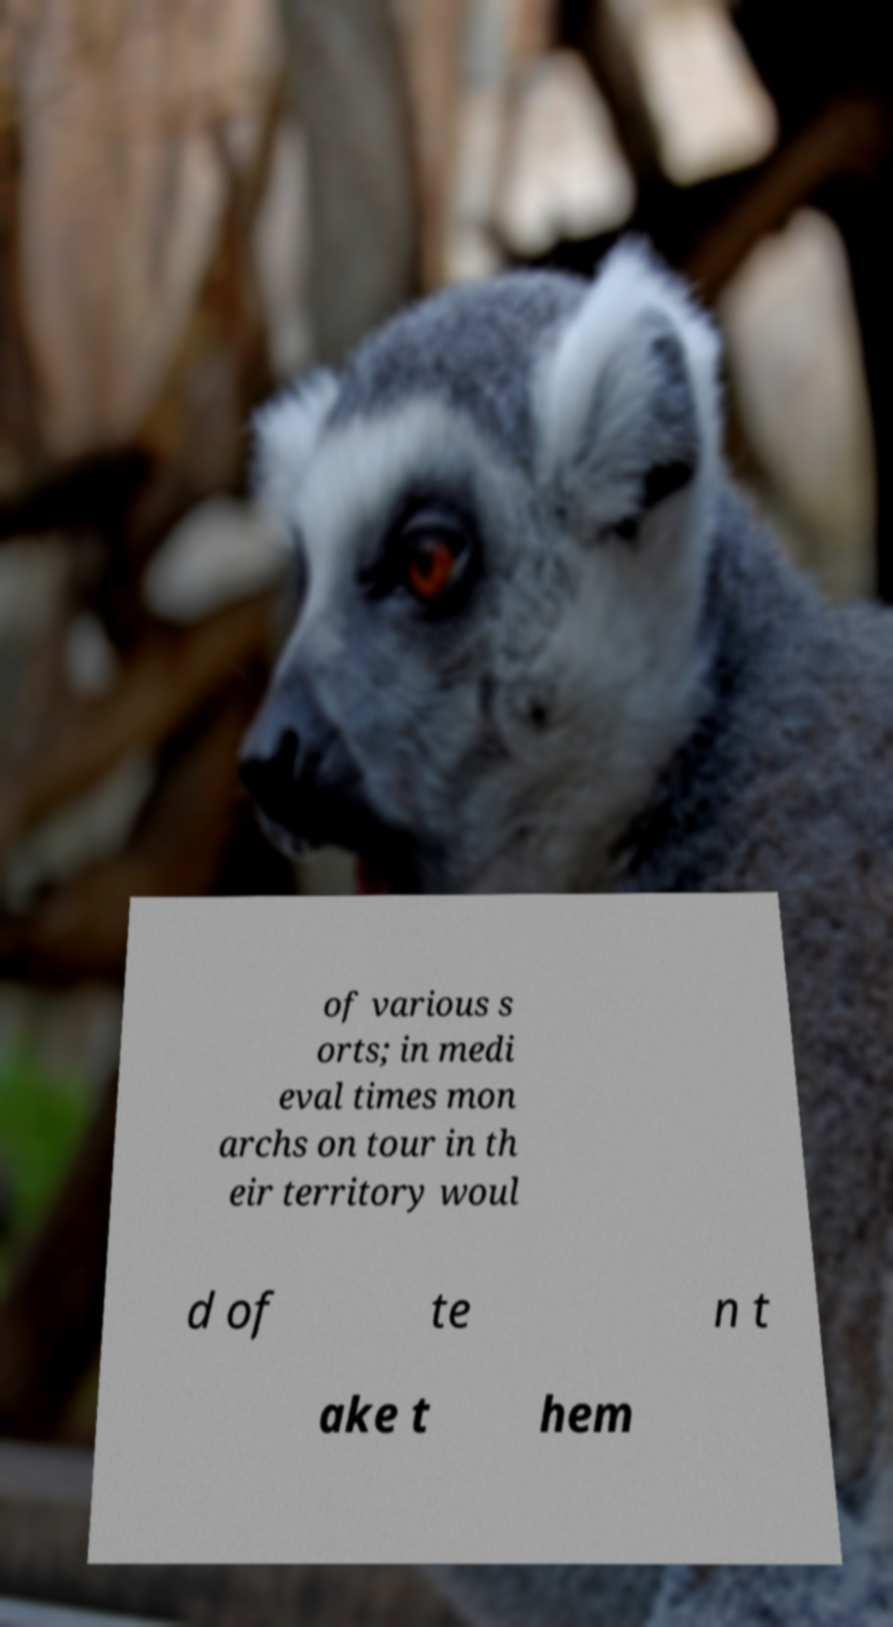Could you extract and type out the text from this image? of various s orts; in medi eval times mon archs on tour in th eir territory woul d of te n t ake t hem 